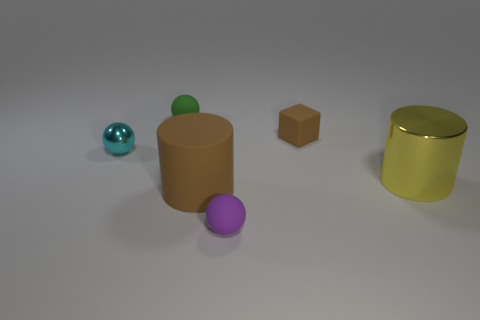There is a purple object that is the same shape as the cyan metal object; what is it made of?
Ensure brevity in your answer.  Rubber. Are there more tiny green matte spheres on the right side of the tiny metal object than brown matte blocks that are in front of the large yellow metallic cylinder?
Provide a short and direct response. Yes. What shape is the large brown object that is made of the same material as the small purple object?
Provide a succinct answer. Cylinder. What number of other things are there of the same shape as the tiny brown matte object?
Your answer should be compact. 0. The large thing behind the brown rubber cylinder has what shape?
Ensure brevity in your answer.  Cylinder. The rubber cylinder has what color?
Provide a short and direct response. Brown. How many other objects are there of the same size as the purple thing?
Your answer should be compact. 3. What is the material of the small sphere that is to the right of the small ball that is behind the small matte block?
Keep it short and to the point. Rubber. There is a cyan shiny object; is its size the same as the metallic thing to the right of the big brown rubber cylinder?
Keep it short and to the point. No. Is there a small object of the same color as the large matte cylinder?
Offer a very short reply. Yes. 